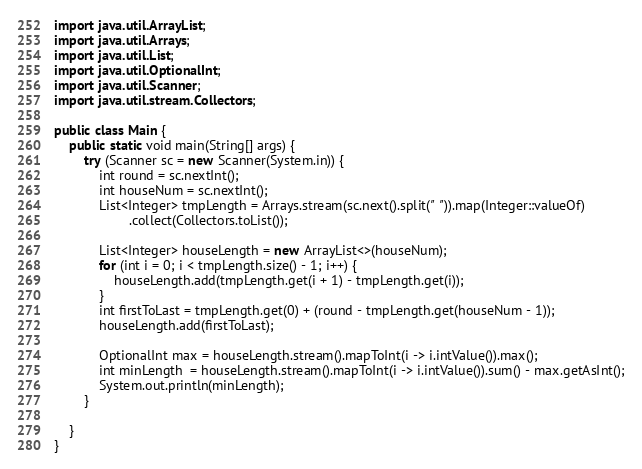<code> <loc_0><loc_0><loc_500><loc_500><_Java_>import java.util.ArrayList;
import java.util.Arrays;
import java.util.List;
import java.util.OptionalInt;
import java.util.Scanner;
import java.util.stream.Collectors;

public class Main {
	public static void main(String[] args) {
		try (Scanner sc = new Scanner(System.in)) {
			int round = sc.nextInt();
			int houseNum = sc.nextInt();
			List<Integer> tmpLength = Arrays.stream(sc.next().split(" ")).map(Integer::valueOf)
					.collect(Collectors.toList());

			List<Integer> houseLength = new ArrayList<>(houseNum);
			for (int i = 0; i < tmpLength.size() - 1; i++) {
				houseLength.add(tmpLength.get(i + 1) - tmpLength.get(i));
			}
			int firstToLast = tmpLength.get(0) + (round - tmpLength.get(houseNum - 1));
			houseLength.add(firstToLast);
			
			OptionalInt max = houseLength.stream().mapToInt(i -> i.intValue()).max();
			int minLength  = houseLength.stream().mapToInt(i -> i.intValue()).sum() - max.getAsInt();
			System.out.println(minLength);
		}

	}
}</code> 